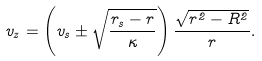Convert formula to latex. <formula><loc_0><loc_0><loc_500><loc_500>v _ { z } = \left ( v _ { s } \pm \sqrt { \frac { r _ { s } - r } { \kappa } } \right ) \frac { \sqrt { r ^ { 2 } - R ^ { 2 } } } { r } .</formula> 